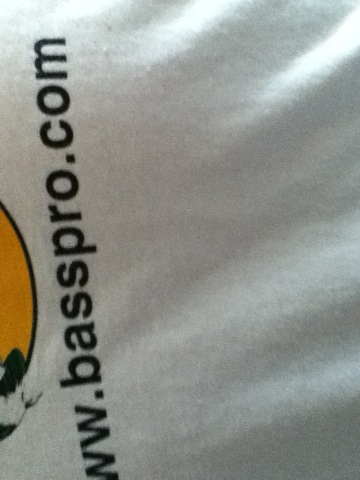What is on this shirt? The shirt features the logo and web address of Bass Pro Shops, an American retailer specializing in outdoor recreation merchandise. The visible part of the shirt shows the text 'www.basspro.com', indicating it's likely promotional or branded merchandise from the company. 